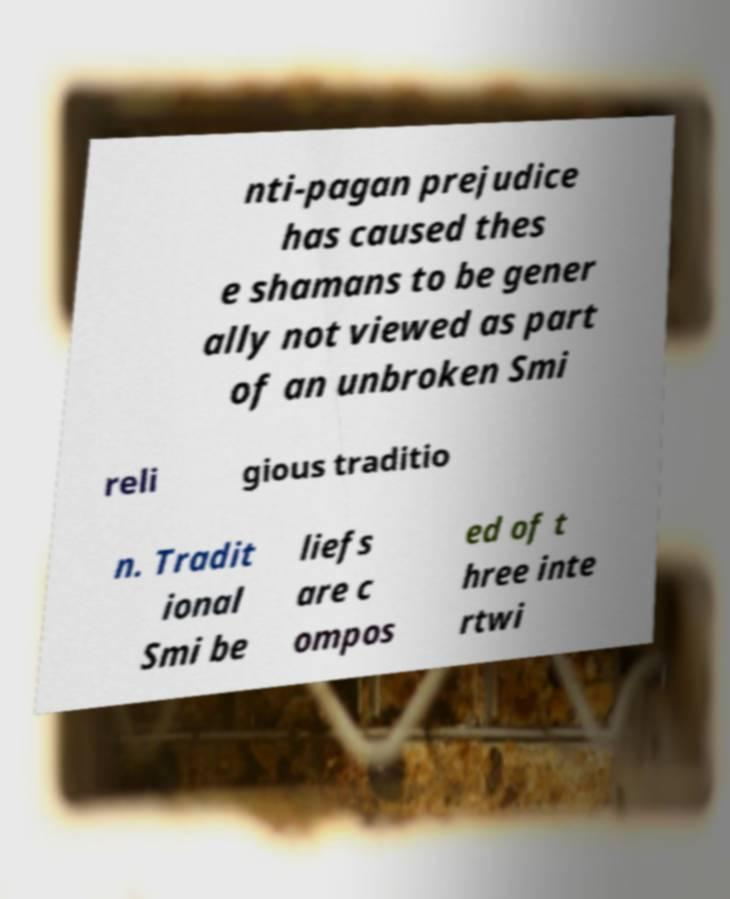Can you read and provide the text displayed in the image?This photo seems to have some interesting text. Can you extract and type it out for me? nti-pagan prejudice has caused thes e shamans to be gener ally not viewed as part of an unbroken Smi reli gious traditio n. Tradit ional Smi be liefs are c ompos ed of t hree inte rtwi 